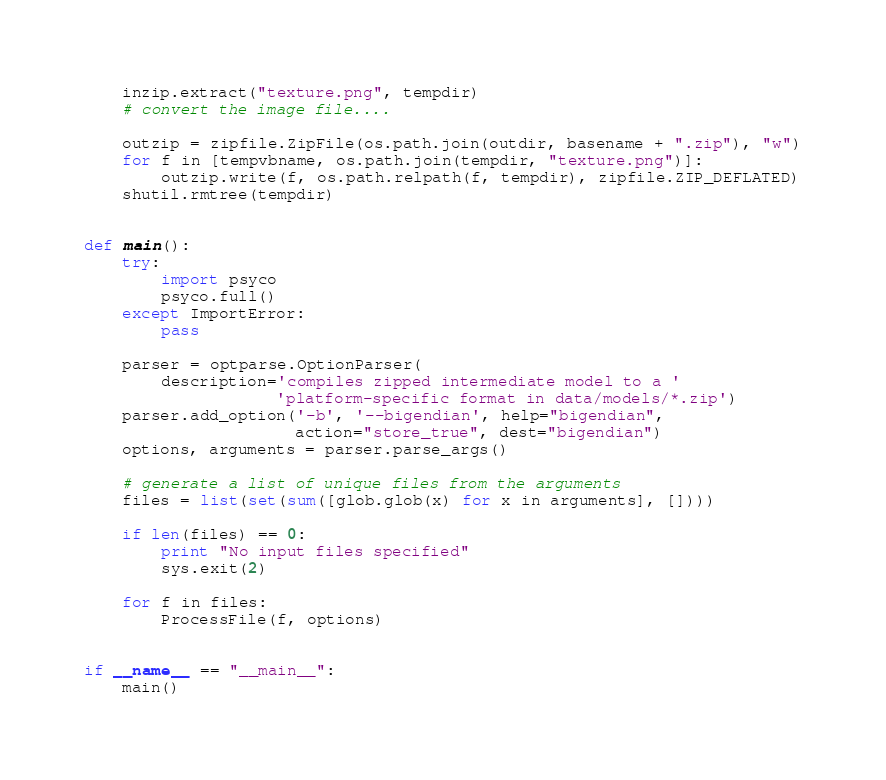<code> <loc_0><loc_0><loc_500><loc_500><_Python_>
    inzip.extract("texture.png", tempdir)
    # convert the image file....

    outzip = zipfile.ZipFile(os.path.join(outdir, basename + ".zip"), "w")
    for f in [tempvbname, os.path.join(tempdir, "texture.png")]:
        outzip.write(f, os.path.relpath(f, tempdir), zipfile.ZIP_DEFLATED)
    shutil.rmtree(tempdir)


def main():
    try:
        import psyco
        psyco.full()
    except ImportError:
        pass

    parser = optparse.OptionParser(
        description='compiles zipped intermediate model to a '
                    'platform-specific format in data/models/*.zip')
    parser.add_option('-b', '--bigendian', help="bigendian",
                      action="store_true", dest="bigendian")
    options, arguments = parser.parse_args()

    # generate a list of unique files from the arguments
    files = list(set(sum([glob.glob(x) for x in arguments], [])))

    if len(files) == 0:
        print "No input files specified"
        sys.exit(2)

    for f in files:
        ProcessFile(f, options)


if __name__ == "__main__":
    main()
</code> 